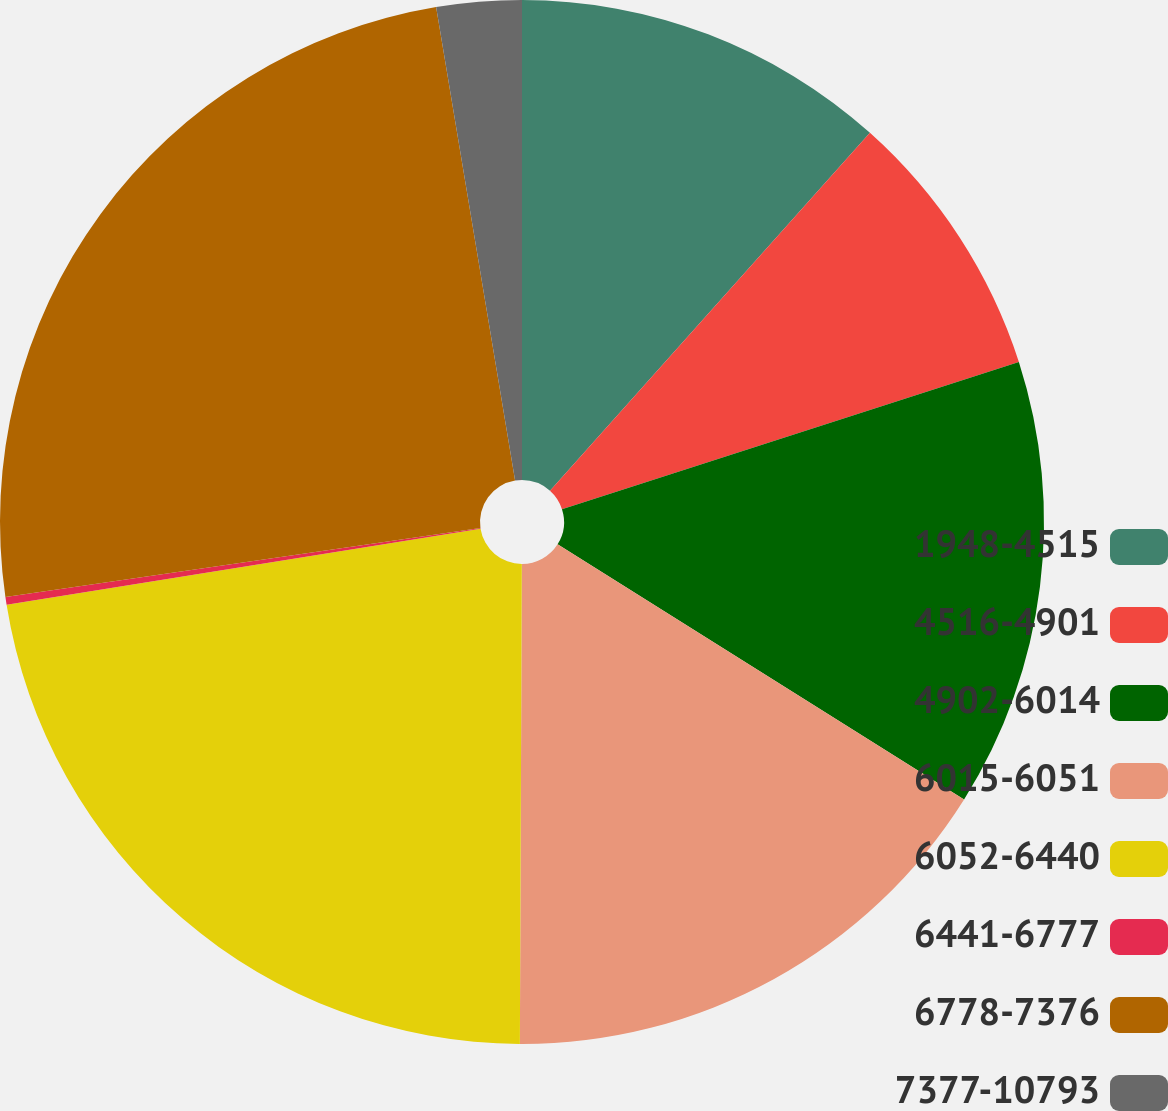Convert chart to OTSL. <chart><loc_0><loc_0><loc_500><loc_500><pie_chart><fcel>1948-4515<fcel>4516-4901<fcel>4902-6014<fcel>6015-6051<fcel>6052-6440<fcel>6441-6777<fcel>6778-7376<fcel>7377-10793<nl><fcel>11.61%<fcel>8.43%<fcel>13.88%<fcel>16.14%<fcel>22.4%<fcel>0.24%<fcel>24.66%<fcel>2.63%<nl></chart> 